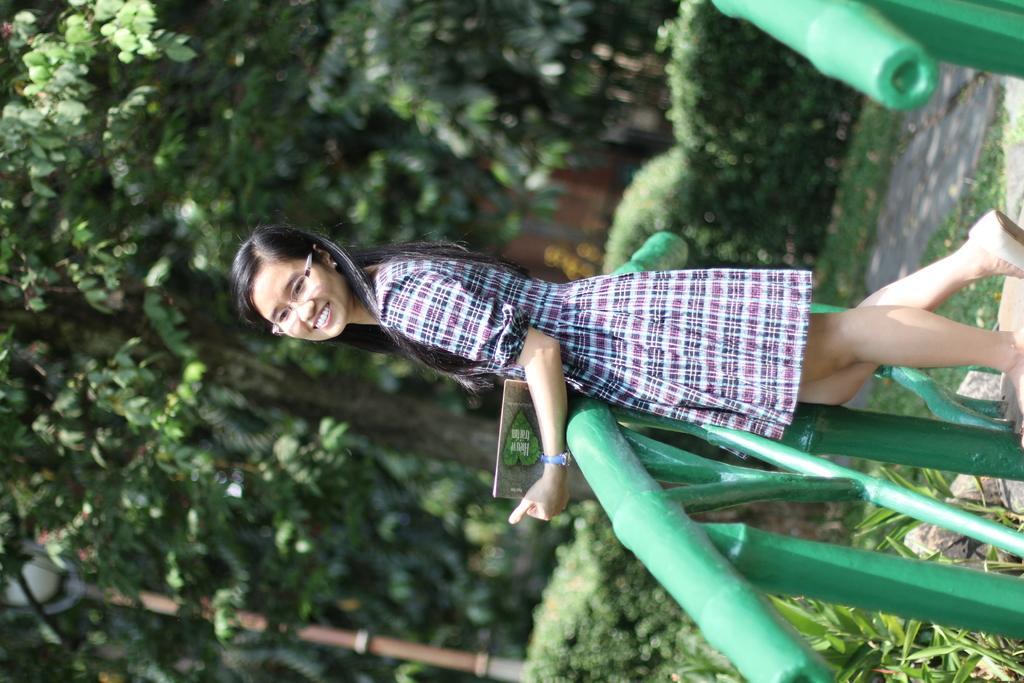In one or two sentences, can you explain what this image depicts? In this picture there is a woman standing and smiling and holding an object. We can see grass, plants and fence. In the background of the image we can see trees. 